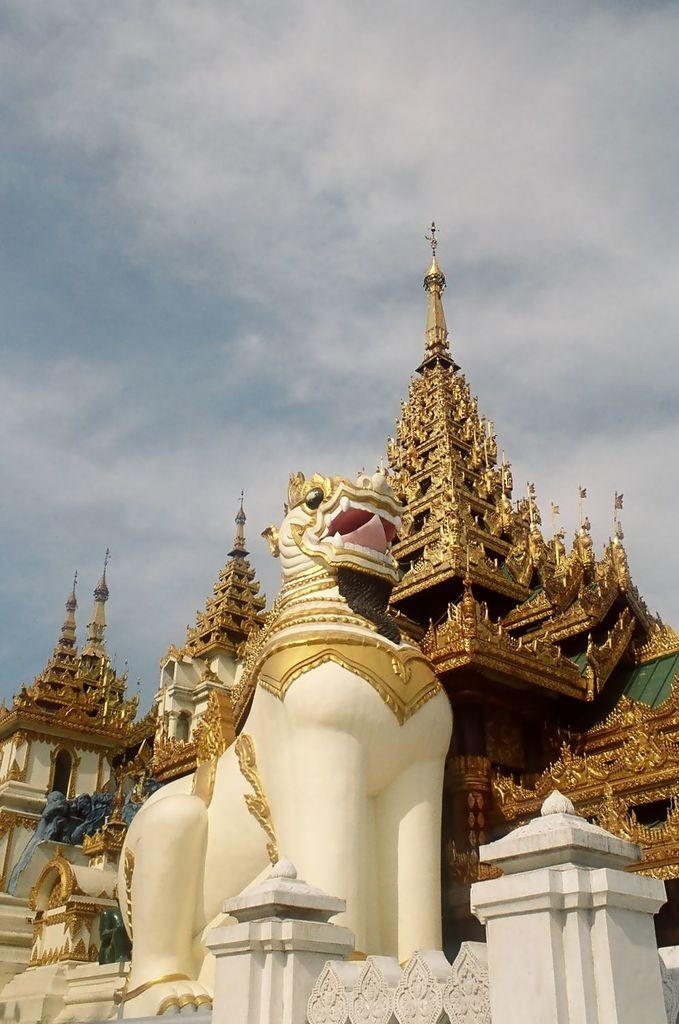What type of building is in the image? There is a big golden Wat temple in the image. What is located in front of the temple? There is a big statue in front of the temple. What is visible at the top of the image? The sky is visible at the top of the image. How does the heat affect the quiver of the statue in the image? There is no mention of heat or a quiver in the image, as it features a big golden Wat temple and a statue in front of it. 